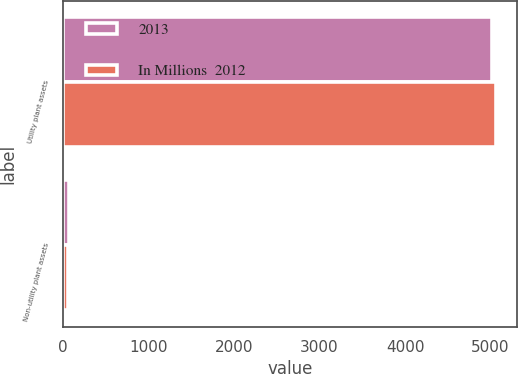Convert chart to OTSL. <chart><loc_0><loc_0><loc_500><loc_500><stacked_bar_chart><ecel><fcel>Utility plant assets<fcel>Non-utility plant assets<nl><fcel>2013<fcel>5021<fcel>66<nl><fcel>In Millions  2012<fcel>5060<fcel>61<nl></chart> 